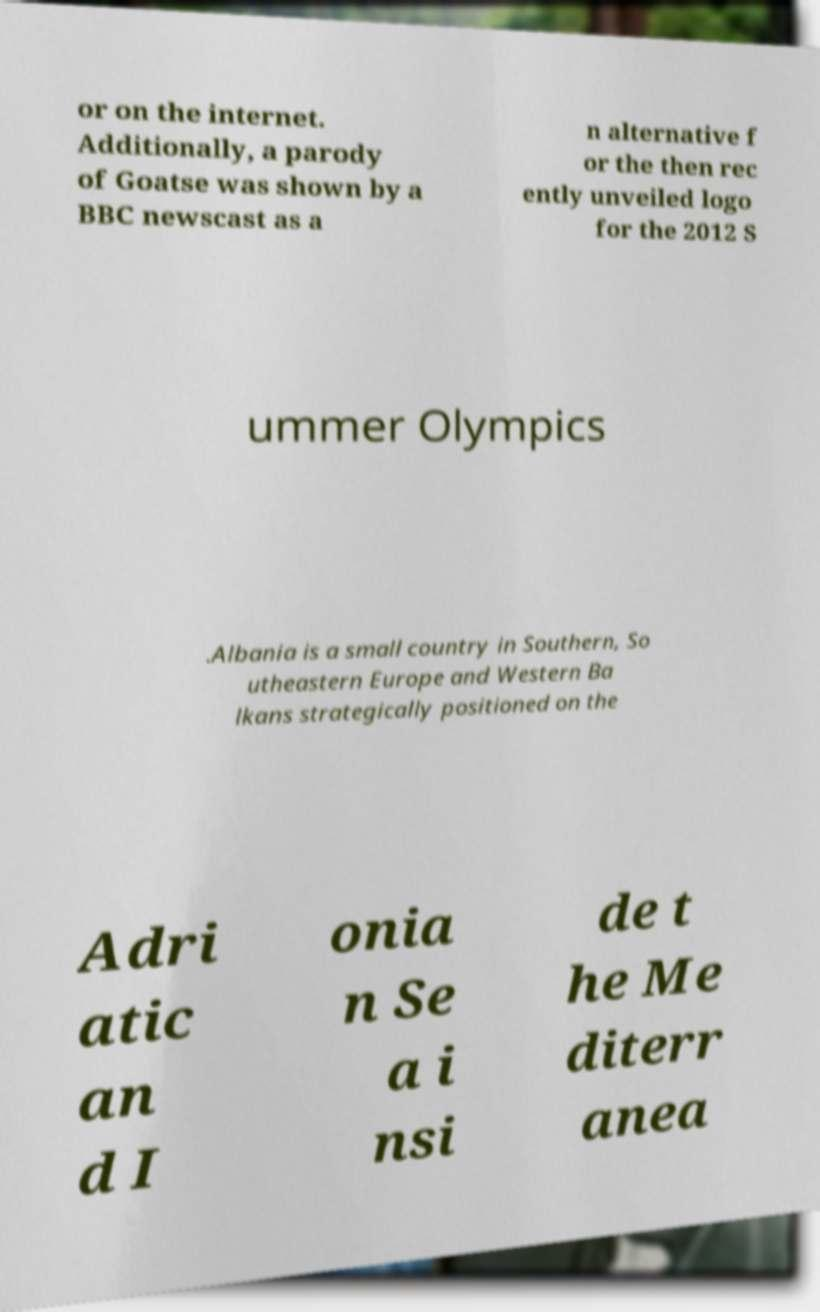Could you assist in decoding the text presented in this image and type it out clearly? or on the internet. Additionally, a parody of Goatse was shown by a BBC newscast as a n alternative f or the then rec ently unveiled logo for the 2012 S ummer Olympics .Albania is a small country in Southern, So utheastern Europe and Western Ba lkans strategically positioned on the Adri atic an d I onia n Se a i nsi de t he Me diterr anea 